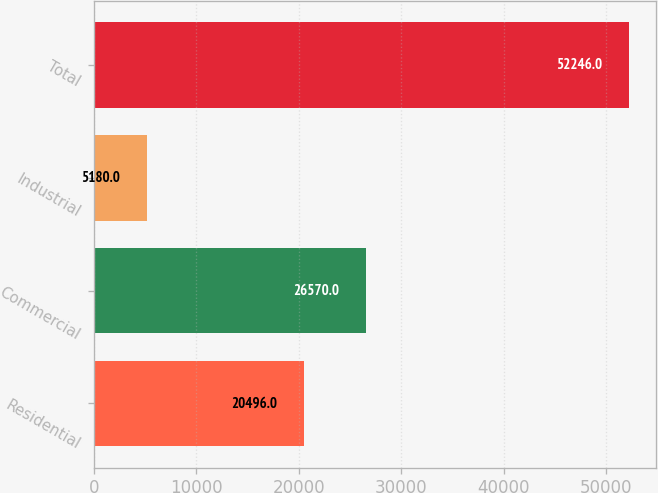<chart> <loc_0><loc_0><loc_500><loc_500><bar_chart><fcel>Residential<fcel>Commercial<fcel>Industrial<fcel>Total<nl><fcel>20496<fcel>26570<fcel>5180<fcel>52246<nl></chart> 